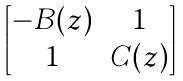Convert formula to latex. <formula><loc_0><loc_0><loc_500><loc_500>\begin{bmatrix} - B ( z ) & 1 \\ 1 & C ( z ) \end{bmatrix}</formula> 